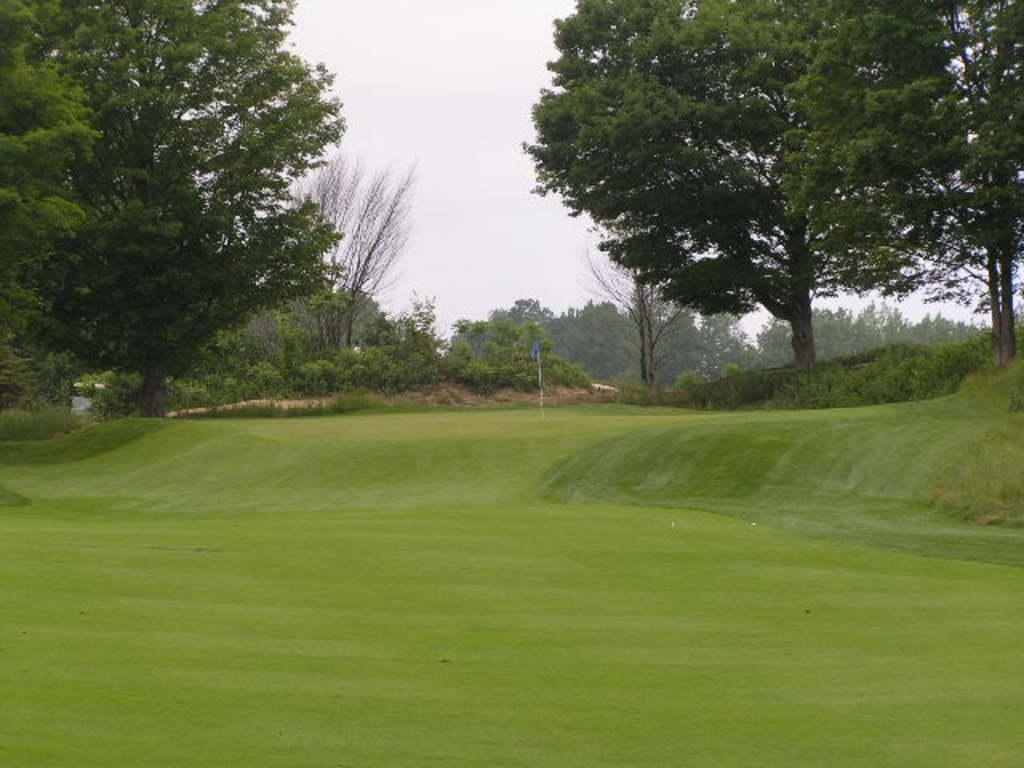What type of vegetation can be seen in the image? There is grass, plants, and trees in the image. What structure is present in the image? There is a pole in the image. What type of buildings can be seen in the image? There are houses in the image. What part of the natural environment is visible in the image? The sky is visible in the image. Can you describe the setting where the image might have been taken? The image may have been taken in a park, given the presence of grass, plants, trees, and the open space. What type of match is being played in the image? There is no match being played in the image; it features grass, plants, trees, a pole, houses, and the sky. What type of agreement is being made between the trees in the image? There is no agreement being made between the trees in the image; they are simply standing in the park. 